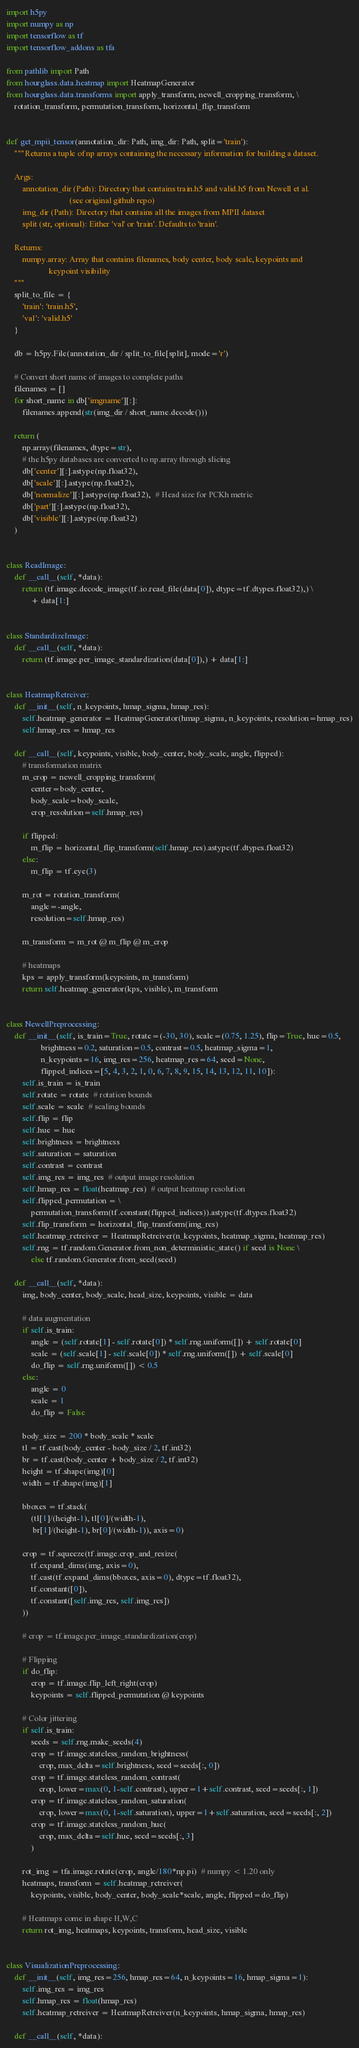Convert code to text. <code><loc_0><loc_0><loc_500><loc_500><_Python_>import h5py
import numpy as np
import tensorflow as tf
import tensorflow_addons as tfa

from pathlib import Path
from hourglass.data.heatmap import HeatmapGenerator
from hourglass.data.transforms import apply_transform, newell_cropping_transform, \
    rotation_transform, permutation_transform, horizontal_flip_transform


def get_mpii_tensor(annotation_dir: Path, img_dir: Path, split='train'):
    """Returns a tuple of np arrays containing the necessary information for building a dataset.

    Args:
        annotation_dir (Path): Directory that contains train.h5 and valid.h5 from Newell et al.
                               (see original github repo)
        img_dir (Path): Directory that contains all the images from MPII dataset
        split (str, optional): Either 'val' or 'train'. Defaults to 'train'.

    Returns:
        numpy.array: Array that contains filenames, body center, body scale, keypoints and
                     keypoint visibility
    """
    split_to_file = {
        'train': 'train.h5',
        'val': 'valid.h5'
    }

    db = h5py.File(annotation_dir / split_to_file[split], mode='r')

    # Convert short name of images to complete paths
    filenames = []
    for short_name in db['imgname'][:]:
        filenames.append(str(img_dir / short_name.decode()))

    return (
        np.array(filenames, dtype=str),
        # the h5py databases are converted to np.array through slicing
        db['center'][:].astype(np.float32),
        db['scale'][:].astype(np.float32),
        db['normalize'][:].astype(np.float32),  # Head size for PCKh metric
        db['part'][:].astype(np.float32),
        db['visible'][:].astype(np.float32)
    )


class ReadImage:
    def __call__(self, *data):
        return (tf.image.decode_image(tf.io.read_file(data[0]), dtype=tf.dtypes.float32),) \
            + data[1:]


class StandardizeImage:
    def __call__(self, *data):
        return (tf.image.per_image_standardization(data[0]),) + data[1:]


class HeatmapRetreiver:
    def __init__(self, n_keypoints, hmap_sigma, hmap_res):
        self.heatmap_generator = HeatmapGenerator(hmap_sigma, n_keypoints, resolution=hmap_res)
        self.hmap_res = hmap_res

    def __call__(self, keypoints, visible, body_center, body_scale, angle, flipped):
        # transformation matrix
        m_crop = newell_cropping_transform(
            center=body_center,
            body_scale=body_scale,
            crop_resolution=self.hmap_res)

        if flipped:
            m_flip = horizontal_flip_transform(self.hmap_res).astype(tf.dtypes.float32)
        else:
            m_flip = tf.eye(3)

        m_rot = rotation_transform(
            angle=-angle,
            resolution=self.hmap_res)

        m_transform = m_rot @ m_flip @ m_crop

        # heatmaps
        kps = apply_transform(keypoints, m_transform)
        return self.heatmap_generator(kps, visible), m_transform


class NewellPreprocessing:
    def __init__(self, is_train=True, rotate=(-30, 30), scale=(0.75, 1.25), flip=True, hue=0.5,
                 brightness=0.2, saturation=0.5, contrast=0.5, heatmap_sigma=1,
                 n_keypoints=16, img_res=256, heatmap_res=64, seed=None,
                 flipped_indices=[5, 4, 3, 2, 1, 0, 6, 7, 8, 9, 15, 14, 13, 12, 11, 10]):
        self.is_train = is_train
        self.rotate = rotate  # rotation bounds
        self.scale = scale  # scaling bounds
        self.flip = flip
        self.hue = hue
        self.brightness = brightness
        self.saturation = saturation
        self.contrast = contrast
        self.img_res = img_res  # output image resolution
        self.hmap_res = float(heatmap_res)  # output heatmap resolution
        self.flipped_permutation = \
            permutation_transform(tf.constant(flipped_indices)).astype(tf.dtypes.float32)
        self.flip_transform = horizontal_flip_transform(img_res)
        self.heatmap_retreiver = HeatmapRetreiver(n_keypoints, heatmap_sigma, heatmap_res)
        self.rng = tf.random.Generator.from_non_deterministic_state() if seed is None \
            else tf.random.Generator.from_seed(seed)

    def __call__(self, *data):
        img, body_center, body_scale, head_size, keypoints, visible = data

        # data augmentation
        if self.is_train:
            angle = (self.rotate[1] - self.rotate[0]) * self.rng.uniform([]) + self.rotate[0]
            scale = (self.scale[1] - self.scale[0]) * self.rng.uniform([]) + self.scale[0]
            do_flip = self.rng.uniform([]) < 0.5
        else:
            angle = 0
            scale = 1
            do_flip = False

        body_size = 200 * body_scale * scale
        tl = tf.cast(body_center - body_size / 2, tf.int32)
        br = tf.cast(body_center + body_size / 2, tf.int32)
        height = tf.shape(img)[0]
        width = tf.shape(img)[1]

        bboxes = tf.stack(
            (tl[1]/(height-1), tl[0]/(width-1),
             br[1]/(height-1), br[0]/(width-1)), axis=0)

        crop = tf.squeeze(tf.image.crop_and_resize(
            tf.expand_dims(img, axis=0),
            tf.cast(tf.expand_dims(bboxes, axis=0), dtype=tf.float32),
            tf.constant([0]),
            tf.constant([self.img_res, self.img_res])
        ))

        # crop = tf.image.per_image_standardization(crop)

        # Flipping
        if do_flip:
            crop = tf.image.flip_left_right(crop)
            keypoints = self.flipped_permutation @ keypoints

        # Color jittering
        if self.is_train:
            seeds = self.rng.make_seeds(4)
            crop = tf.image.stateless_random_brightness(
                crop, max_delta=self.brightness, seed=seeds[:, 0])
            crop = tf.image.stateless_random_contrast(
                crop, lower=max(0, 1-self.contrast), upper=1+self.contrast, seed=seeds[:, 1])
            crop = tf.image.stateless_random_saturation(
                crop, lower=max(0, 1-self.saturation), upper=1+self.saturation, seed=seeds[:, 2])
            crop = tf.image.stateless_random_hue(
                crop, max_delta=self.hue, seed=seeds[:, 3]
            )

        rot_img = tfa.image.rotate(crop, angle/180*np.pi)  # numpy < 1.20 only
        heatmaps, transform = self.heatmap_retreiver(
            keypoints, visible, body_center, body_scale*scale, angle, flipped=do_flip)

        # Heatmaps come in shape H,W,C
        return rot_img, heatmaps, keypoints, transform, head_size, visible


class VisualizationPreprocessing:
    def __init__(self, img_res=256, hmap_res=64, n_keypoints=16, hmap_sigma=1):
        self.img_res = img_res
        self.hmap_res = float(hmap_res)
        self.heatmap_retreiver = HeatmapRetreiver(n_keypoints, hmap_sigma, hmap_res)

    def __call__(self, *data):</code> 